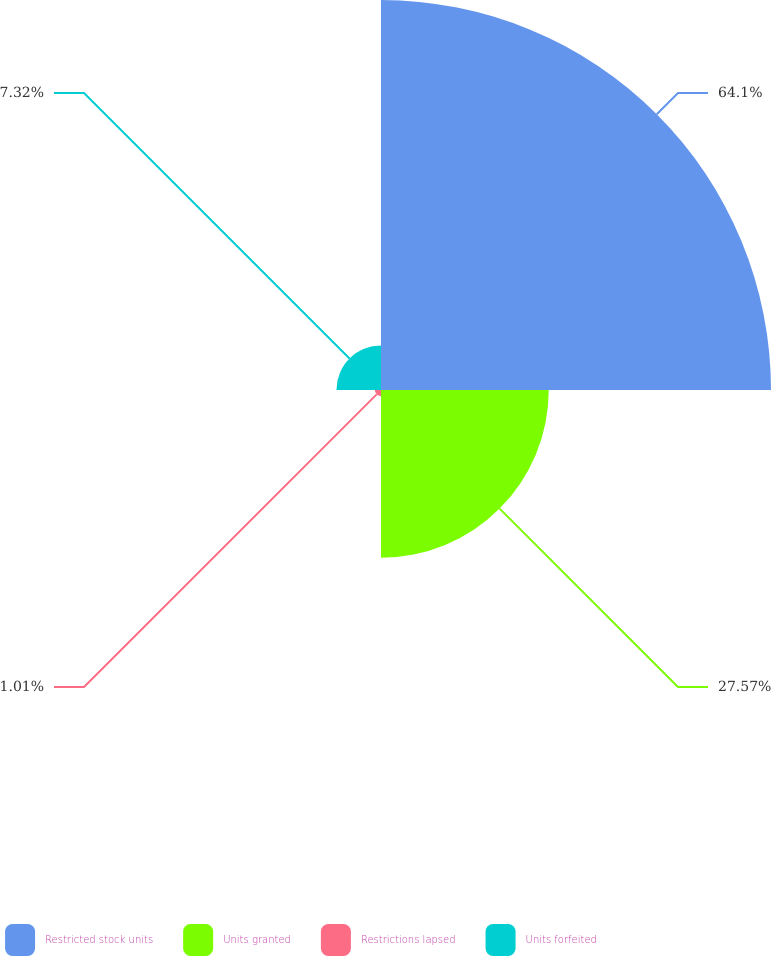Convert chart to OTSL. <chart><loc_0><loc_0><loc_500><loc_500><pie_chart><fcel>Restricted stock units<fcel>Units granted<fcel>Restrictions lapsed<fcel>Units forfeited<nl><fcel>64.1%<fcel>27.57%<fcel>1.01%<fcel>7.32%<nl></chart> 